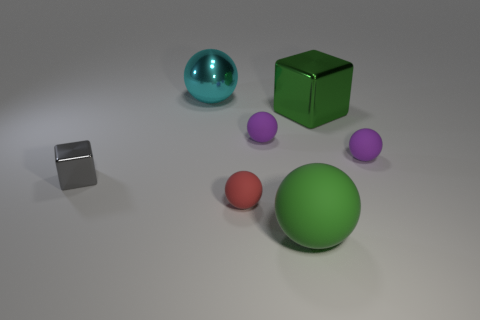Subtract all shiny spheres. How many spheres are left? 4 Add 2 purple rubber balls. How many objects exist? 9 Subtract all blue blocks. How many purple spheres are left? 2 Subtract 1 balls. How many balls are left? 4 Subtract all cyan spheres. How many spheres are left? 4 Subtract all cubes. How many objects are left? 5 Subtract all tiny red rubber things. Subtract all big objects. How many objects are left? 3 Add 3 green shiny things. How many green shiny things are left? 4 Add 5 brown matte balls. How many brown matte balls exist? 5 Subtract 0 gray cylinders. How many objects are left? 7 